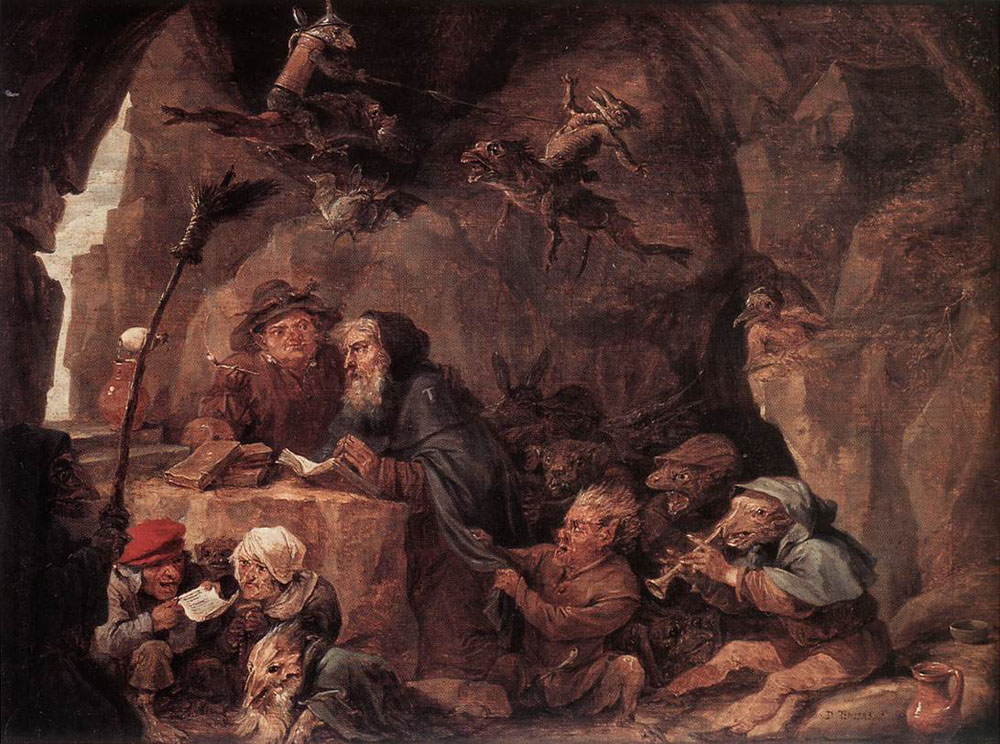Can you elaborate on the elements of the picture provided? The oil painting you're referring to portrays a fascinating scene set within a cavern. Painted in the Baroque style, it vividly utilizes dramatic contrasts between light and shadow to emphasize the depth of the cave and the liveliness of the scene. This artwork centers around a group of dwarves who are depicted engaging in various activities around a rustic table, some absorbed in reading, others conversing, and a few enjoying drinks. Notably, although the palette primarily features dark tones, the skillful placement of light sources and the white beards of the dwarves add a captivating contrast and warmth to the painting. Such scenes, often called genre paintings, offer a glimpse into mythical or everyday life while imbuing it with realism and emotional depth. The artist's mastery in rendering intricate details and textures is noteworthy, presenting the dwarves with a sense of individuality and animation that draws viewers into their world. 